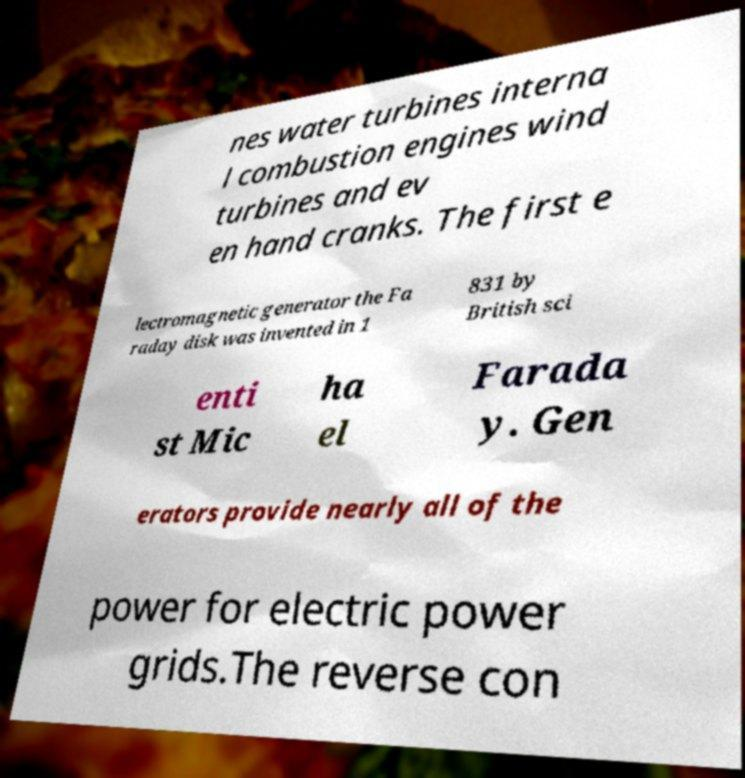Could you extract and type out the text from this image? nes water turbines interna l combustion engines wind turbines and ev en hand cranks. The first e lectromagnetic generator the Fa raday disk was invented in 1 831 by British sci enti st Mic ha el Farada y. Gen erators provide nearly all of the power for electric power grids.The reverse con 